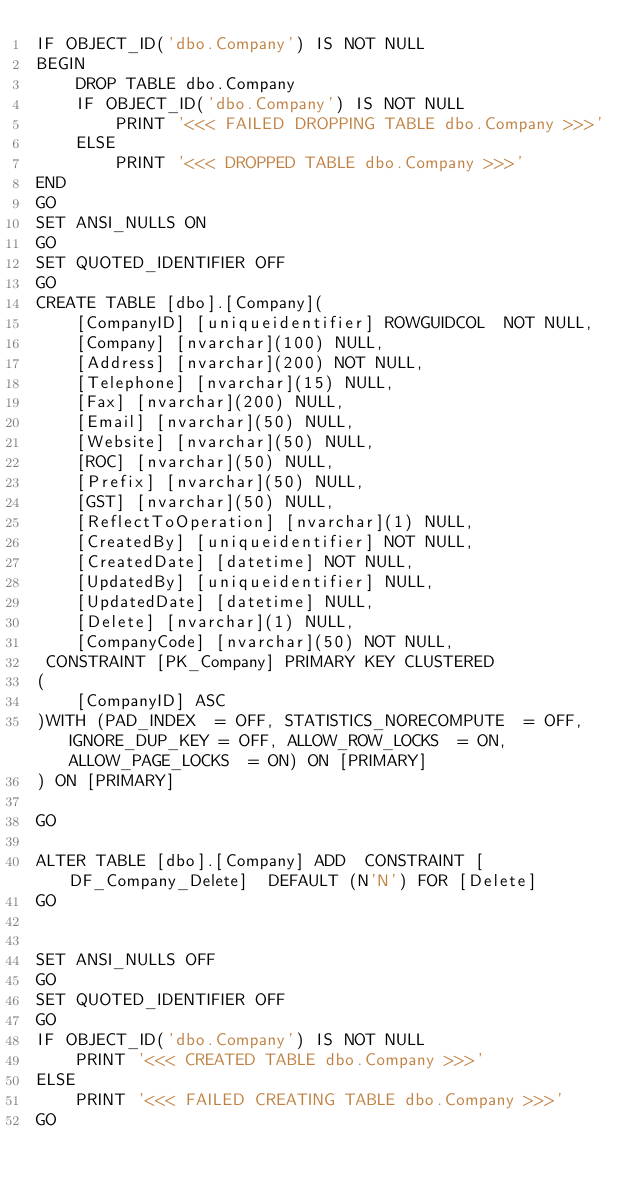<code> <loc_0><loc_0><loc_500><loc_500><_SQL_>IF OBJECT_ID('dbo.Company') IS NOT NULL
BEGIN
    DROP TABLE dbo.Company
    IF OBJECT_ID('dbo.Company') IS NOT NULL
        PRINT '<<< FAILED DROPPING TABLE dbo.Company >>>'
    ELSE
        PRINT '<<< DROPPED TABLE dbo.Company >>>'
END
GO
SET ANSI_NULLS ON
GO
SET QUOTED_IDENTIFIER OFF
GO
CREATE TABLE [dbo].[Company](
	[CompanyID] [uniqueidentifier] ROWGUIDCOL  NOT NULL,
	[Company] [nvarchar](100) NULL,
	[Address] [nvarchar](200) NOT NULL,
	[Telephone] [nvarchar](15) NULL,
	[Fax] [nvarchar](200) NULL,
	[Email] [nvarchar](50) NULL,
	[Website] [nvarchar](50) NULL,
	[ROC] [nvarchar](50) NULL,
	[Prefix] [nvarchar](50) NULL,
	[GST] [nvarchar](50) NULL,
	[ReflectToOperation] [nvarchar](1) NULL,
	[CreatedBy] [uniqueidentifier] NOT NULL,
	[CreatedDate] [datetime] NOT NULL,
	[UpdatedBy] [uniqueidentifier] NULL,
	[UpdatedDate] [datetime] NULL,
	[Delete] [nvarchar](1) NULL,
	[CompanyCode] [nvarchar](50) NOT NULL,
 CONSTRAINT [PK_Company] PRIMARY KEY CLUSTERED 
(
	[CompanyID] ASC
)WITH (PAD_INDEX  = OFF, STATISTICS_NORECOMPUTE  = OFF, IGNORE_DUP_KEY = OFF, ALLOW_ROW_LOCKS  = ON, ALLOW_PAGE_LOCKS  = ON) ON [PRIMARY]
) ON [PRIMARY]

GO

ALTER TABLE [dbo].[Company] ADD  CONSTRAINT [DF_Company_Delete]  DEFAULT (N'N') FOR [Delete]
GO


SET ANSI_NULLS OFF
GO
SET QUOTED_IDENTIFIER OFF
GO
IF OBJECT_ID('dbo.Company') IS NOT NULL
    PRINT '<<< CREATED TABLE dbo.Company >>>'
ELSE
    PRINT '<<< FAILED CREATING TABLE dbo.Company >>>'
GO</code> 